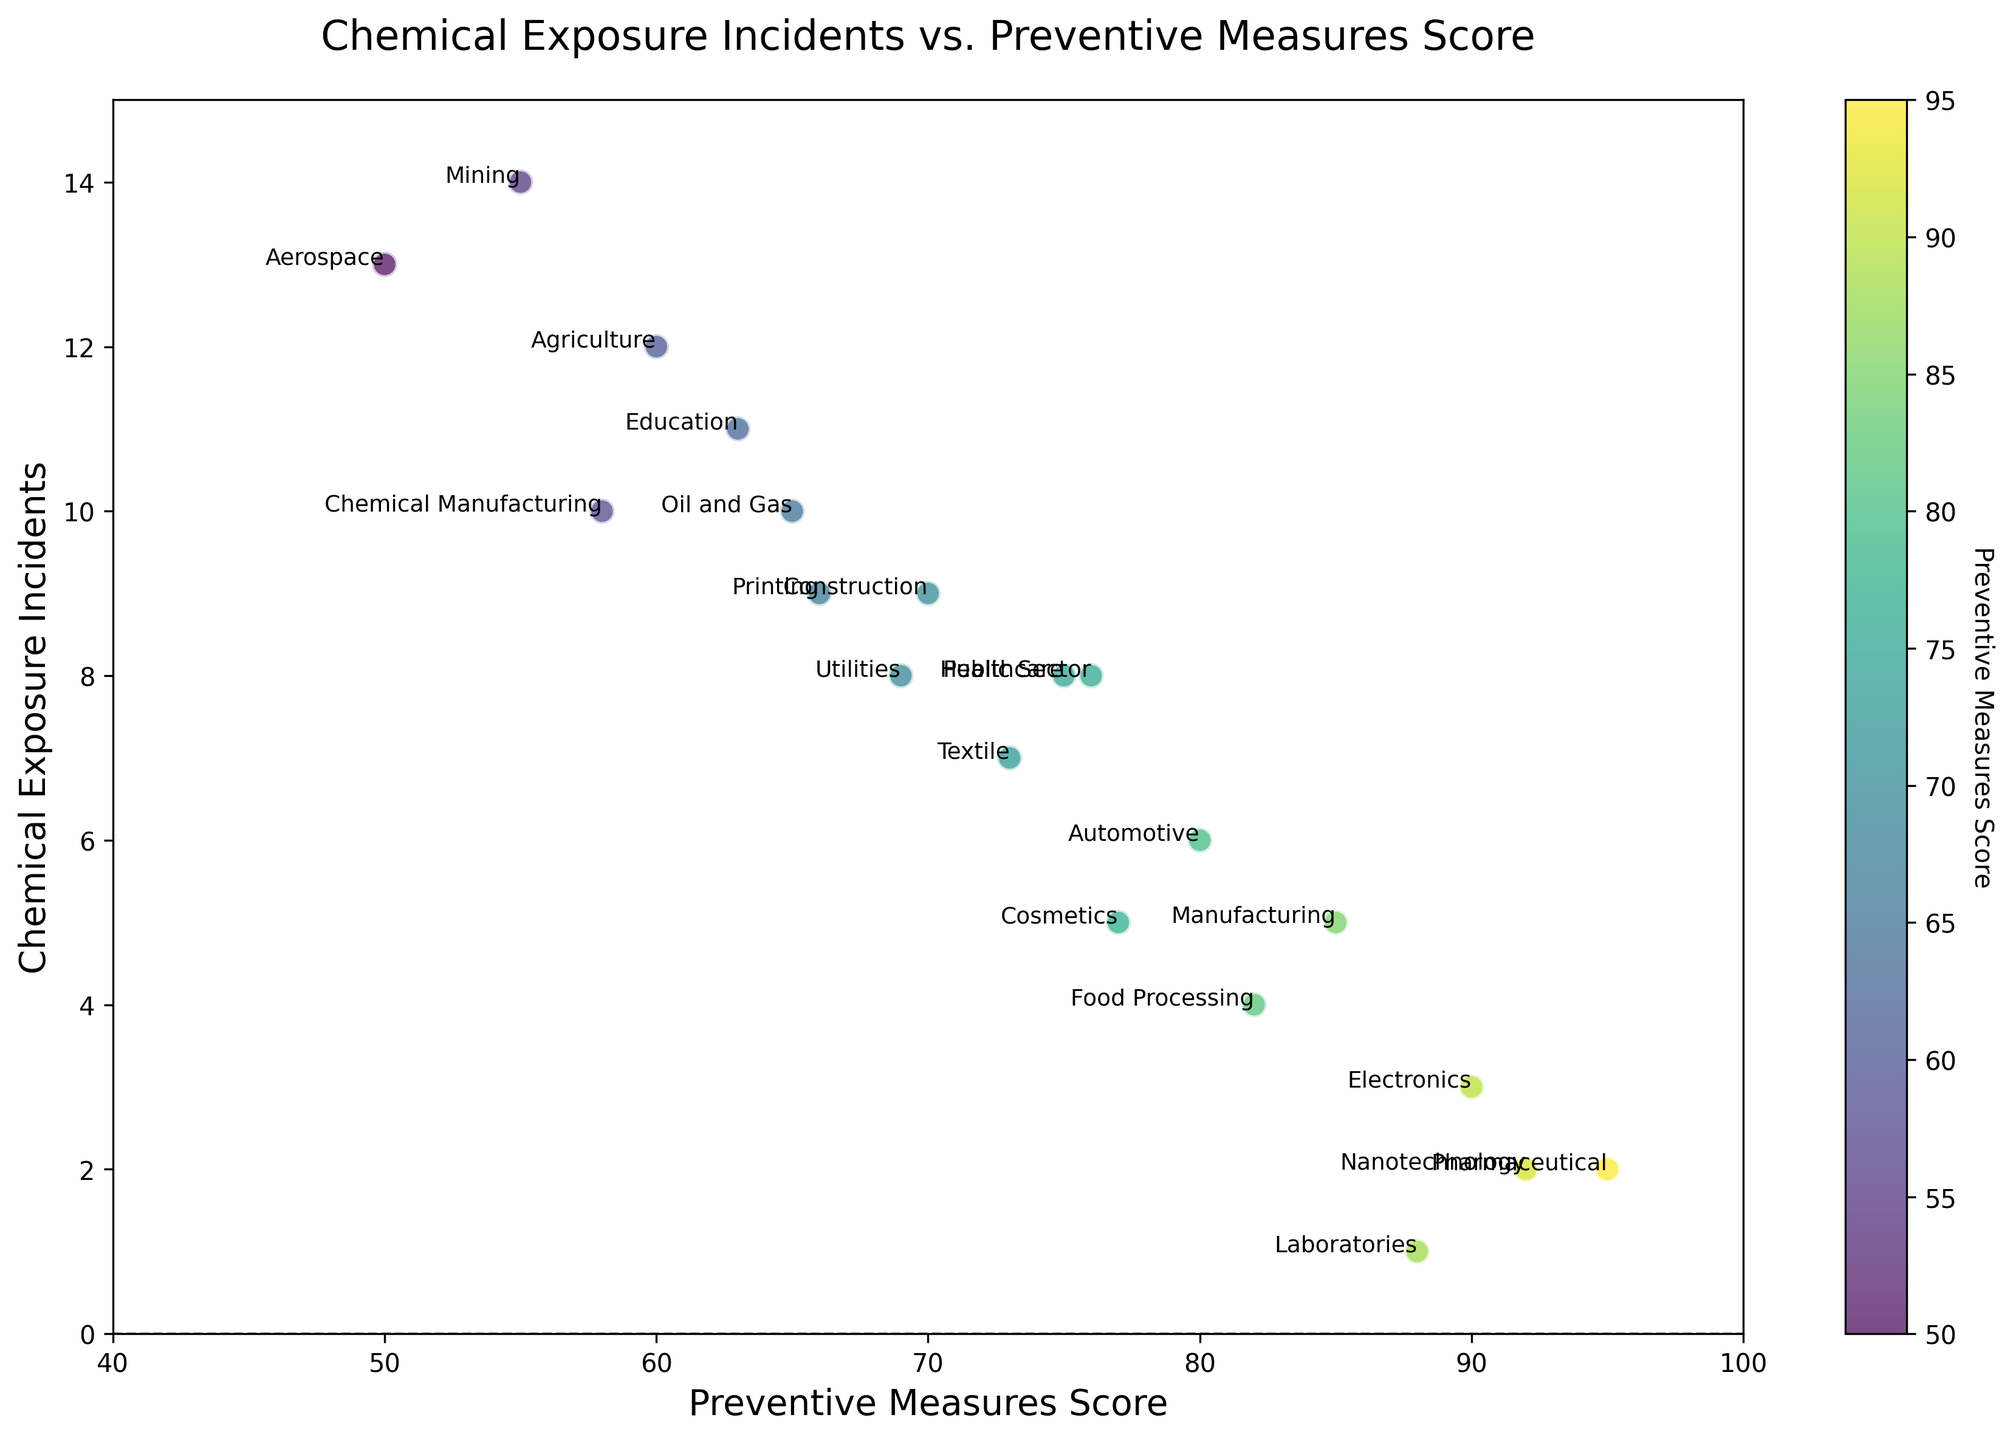What is the relationship between preventive measures score and chemical exposure incidents for the manufacturing industry? By looking at the positioning of the Manufacturing industry on the scatter plot, we can see that a preventive measures score of 85 corresponds to 5 chemical exposure incidents.
Answer: A score of 85 corresponds to 5 incidents Which industry has the lowest number of chemical exposure incidents, and what is its preventive measures score? The Laboratories industry has the lowest number of chemical exposure incidents, which is 1, and has a preventive measures score of 88.
Answer: Laboratories, score 88 Between the Pharmaceutical and the Construction industries, which one has a higher preventive measures score and fewer chemical exposure incidents? The Pharmaceutical industry has a higher preventive measures score (95) and fewer chemical exposure incidents (2) compared to the Construction industry, which has a preventive measures score of 70 and 9 incidents.
Answer: Pharmaceutical What are the coordinates (preventive measures score, chemical exposure incidents) of the industry with the highest chemical exposure incidents? The Mining industry has the highest chemical exposure incidents. Its coordinates on the scatter plot are (55, 14).
Answer: (55, 14) Which industry has a preventive measures score of 72, and how many chemical exposure incidents does it have? No industry has a preventive measures score of 72. We can scan the scatter plot, and 72 does not appear on the x-axis for any industry.
Answer: None How many industries have fewer than 5 chemical exposure incidents? By counting the industries on the scatter plot with fewer than 5 chemical exposure incidents, we find that there are four such industries: Pharmaceutical (2), Nanotechnology (2), Electronics (3), and Food Processing (4).
Answer: 4 industries Between the Oil and Gas and the Automotive industries, which one has more chemical exposure incidents and by how many? The Oil and Gas industry has 10 chemical exposure incidents, while the Automotive industry has 6. The difference between them is 4 incidents.
Answer: Oil and Gas, 4 more What is the average preventive measures score for industries with more than 10 chemical exposure incidents? Three industries have more than 10 chemical exposure incidents: Agriculture (60), Mining (55), and Education (63). Their average preventive measures score is (60 + 55 + 63) / 3 = 59.33.
Answer: 59.33 Which industry is closest to the average value of preventive measures score and chemical exposure incidents for all industries? To find the industry closest to the average values, we first calculate the means: (85+70+95+60+75+65+55+80+73+82+90+88+50+77+66+69+92+63+76+58)/20 = 73.7 for preventive measures, and (5+9+2+12+8+10+14+6+7+4+3+1+13+5+9+8+2+11+8+10)/20 = 7.1 for incidents. The Textile industry (73, 7) is closest to (73.7, 7.1).
Answer: Textile Which industries have a higher preventive measures score but higher chemical exposure incidents compared to the Healthcare industry? The Healthcare industry has a preventive measures score of 75 and 8 chemical exposure incidents. By examining the scatter plot, no industries have higher preventive measures scores and higher chemical exposure incidents than Healthcare.
Answer: None 